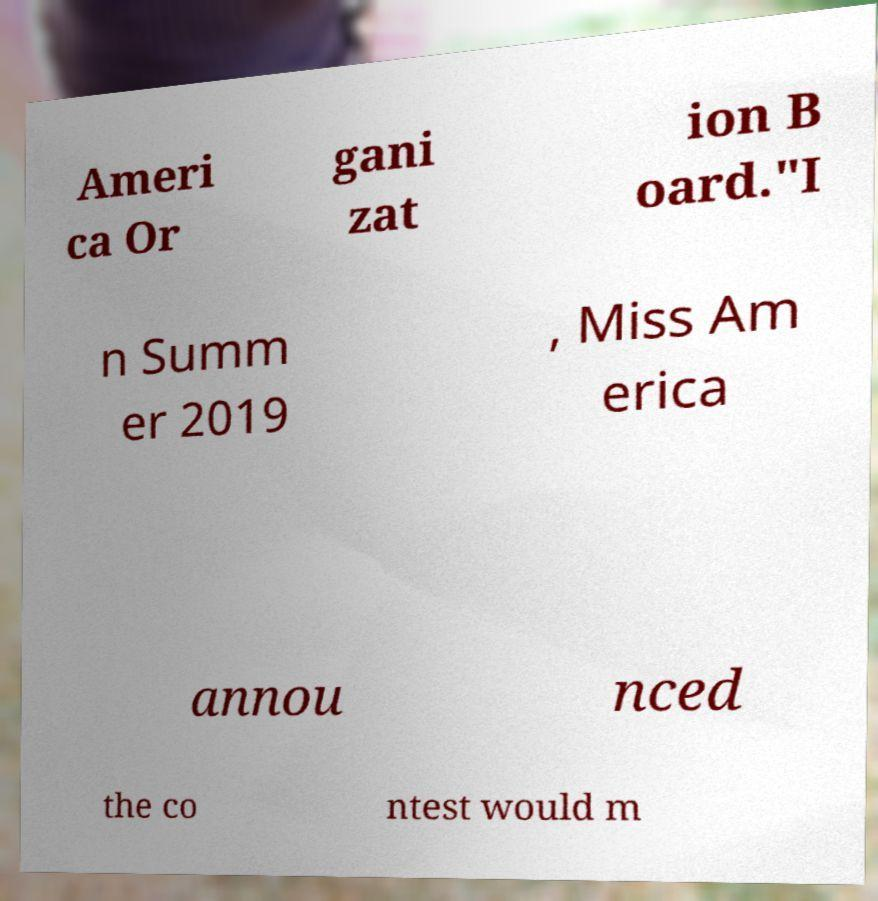What messages or text are displayed in this image? I need them in a readable, typed format. Ameri ca Or gani zat ion B oard."I n Summ er 2019 , Miss Am erica annou nced the co ntest would m 